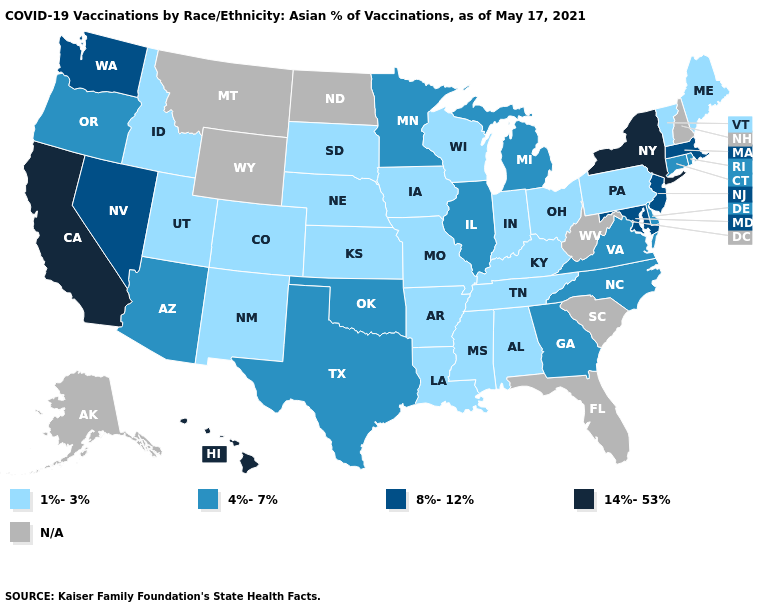Does California have the lowest value in the USA?
Quick response, please. No. Which states have the lowest value in the USA?
Give a very brief answer. Alabama, Arkansas, Colorado, Idaho, Indiana, Iowa, Kansas, Kentucky, Louisiana, Maine, Mississippi, Missouri, Nebraska, New Mexico, Ohio, Pennsylvania, South Dakota, Tennessee, Utah, Vermont, Wisconsin. Name the states that have a value in the range 14%-53%?
Concise answer only. California, Hawaii, New York. What is the lowest value in the South?
Give a very brief answer. 1%-3%. Name the states that have a value in the range N/A?
Be succinct. Alaska, Florida, Montana, New Hampshire, North Dakota, South Carolina, West Virginia, Wyoming. Among the states that border Oregon , which have the highest value?
Give a very brief answer. California. Does the first symbol in the legend represent the smallest category?
Keep it brief. Yes. What is the highest value in states that border Virginia?
Keep it brief. 8%-12%. How many symbols are there in the legend?
Quick response, please. 5. What is the lowest value in the USA?
Short answer required. 1%-3%. What is the value of Alaska?
Short answer required. N/A. What is the value of North Carolina?
Be succinct. 4%-7%. Which states have the lowest value in the Northeast?
Concise answer only. Maine, Pennsylvania, Vermont. Among the states that border Ohio , does Michigan have the lowest value?
Short answer required. No. 